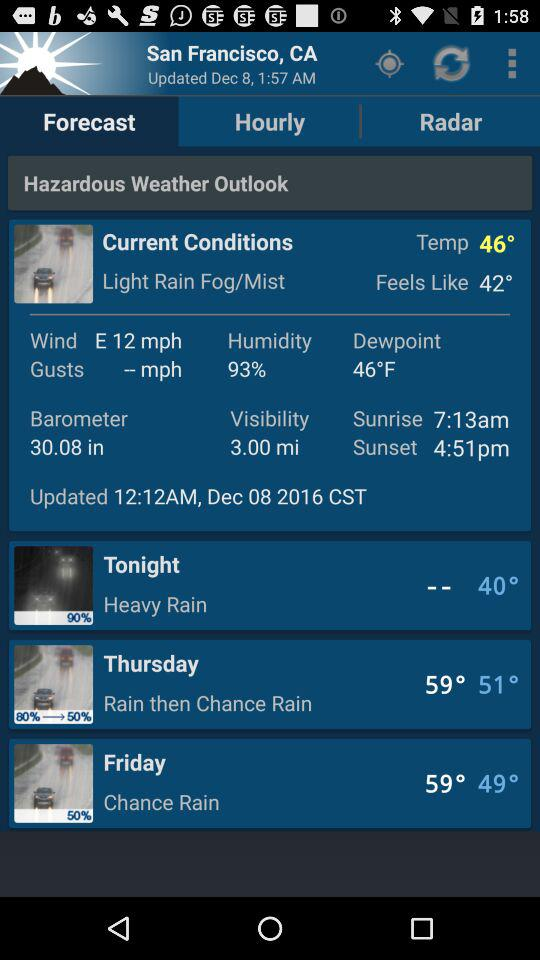How is the wind? The wind is blowing towards the east at a speed of 12 mph. 